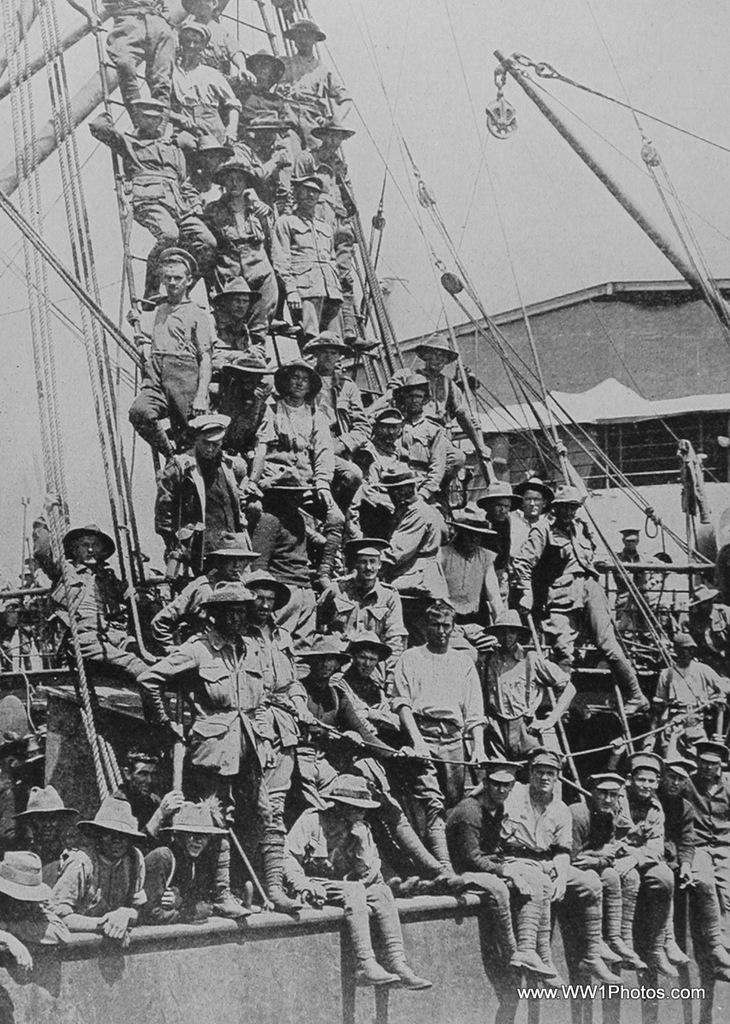What is the main subject of the image? The main subject of the image is a ship. What can be seen on the ship? There are people on the ship. What is visible in the background of the image? There is a building in the image. What objects are present on the ship? There are poles and ropes in the image. What type of marble is being used to construct the building in the image? There is no mention of marble in the image, and the building's construction materials are not visible. Can you see any signs of blood on the ship or the people in the image? There is no indication of blood or any injuries in the image. 